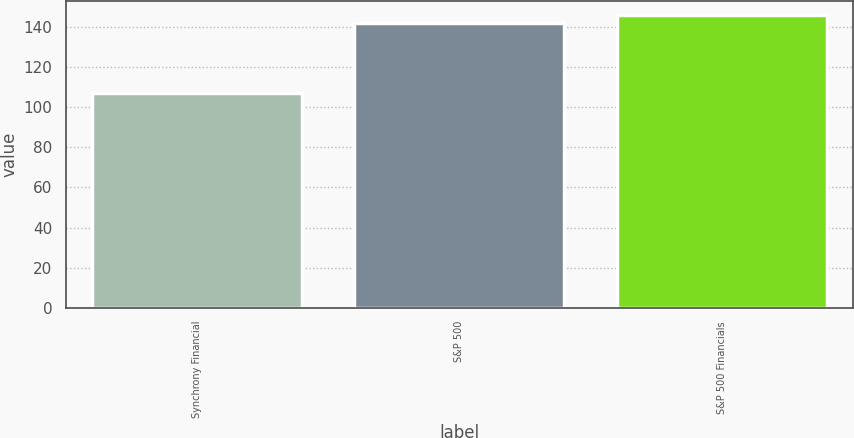Convert chart to OTSL. <chart><loc_0><loc_0><loc_500><loc_500><bar_chart><fcel>Synchrony Financial<fcel>S&P 500<fcel>S&P 500 Financials<nl><fcel>107.21<fcel>142.28<fcel>145.87<nl></chart> 